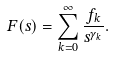Convert formula to latex. <formula><loc_0><loc_0><loc_500><loc_500>F ( s ) = \sum _ { k = 0 } ^ { \infty } \frac { f _ { k } } { s ^ { \gamma _ { k } } } .</formula> 